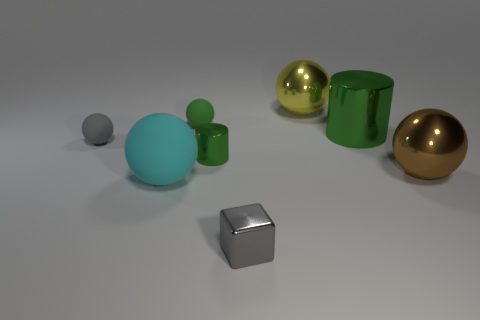How many brown metal things are the same size as the gray ball? After examining the objects, there are no brown metal things that match the size of the gray ball exactly. However, if we are not strictly limited to color and material, there is one object, a gray cube, which appears to be closest in size to the gray ball. 